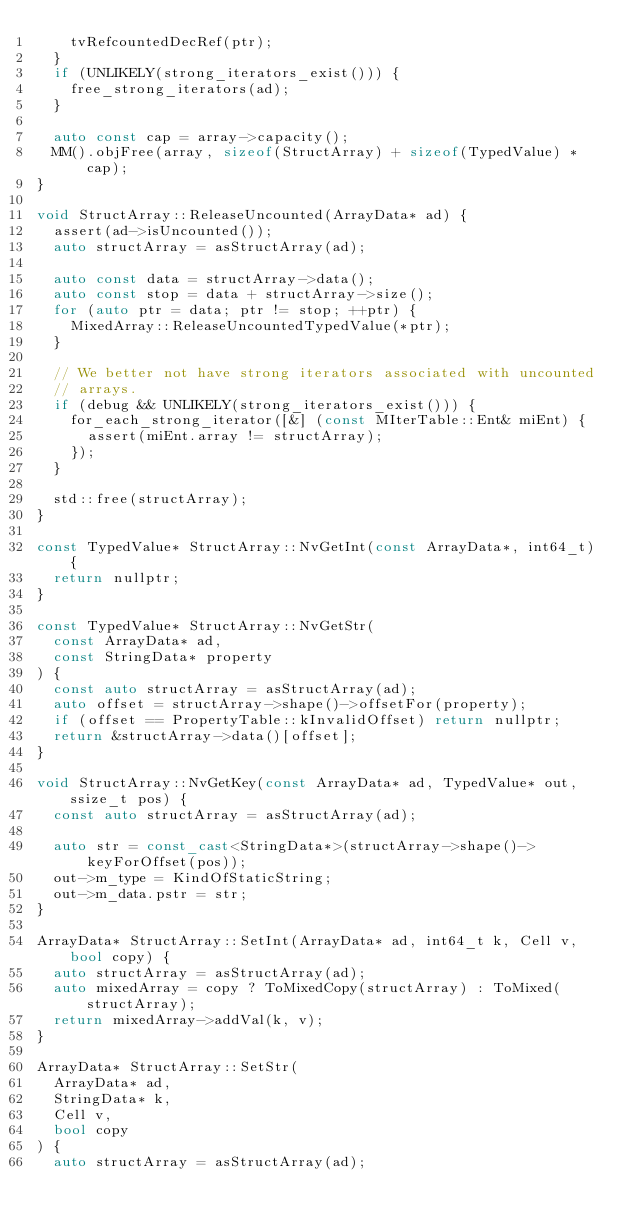<code> <loc_0><loc_0><loc_500><loc_500><_C++_>    tvRefcountedDecRef(ptr);
  }
  if (UNLIKELY(strong_iterators_exist())) {
    free_strong_iterators(ad);
  }

  auto const cap = array->capacity();
  MM().objFree(array, sizeof(StructArray) + sizeof(TypedValue) * cap);
}

void StructArray::ReleaseUncounted(ArrayData* ad) {
  assert(ad->isUncounted());
  auto structArray = asStructArray(ad);

  auto const data = structArray->data();
  auto const stop = data + structArray->size();
  for (auto ptr = data; ptr != stop; ++ptr) {
    MixedArray::ReleaseUncountedTypedValue(*ptr);
  }

  // We better not have strong iterators associated with uncounted
  // arrays.
  if (debug && UNLIKELY(strong_iterators_exist())) {
    for_each_strong_iterator([&] (const MIterTable::Ent& miEnt) {
      assert(miEnt.array != structArray);
    });
  }

  std::free(structArray);
}

const TypedValue* StructArray::NvGetInt(const ArrayData*, int64_t) {
  return nullptr;
}

const TypedValue* StructArray::NvGetStr(
  const ArrayData* ad,
  const StringData* property
) {
  const auto structArray = asStructArray(ad);
  auto offset = structArray->shape()->offsetFor(property);
  if (offset == PropertyTable::kInvalidOffset) return nullptr;
  return &structArray->data()[offset];
}

void StructArray::NvGetKey(const ArrayData* ad, TypedValue* out, ssize_t pos) {
  const auto structArray = asStructArray(ad);

  auto str = const_cast<StringData*>(structArray->shape()->keyForOffset(pos));
  out->m_type = KindOfStaticString;
  out->m_data.pstr = str;
}

ArrayData* StructArray::SetInt(ArrayData* ad, int64_t k, Cell v, bool copy) {
  auto structArray = asStructArray(ad);
  auto mixedArray = copy ? ToMixedCopy(structArray) : ToMixed(structArray);
  return mixedArray->addVal(k, v);
}

ArrayData* StructArray::SetStr(
  ArrayData* ad,
  StringData* k,
  Cell v,
  bool copy
) {
  auto structArray = asStructArray(ad);</code> 